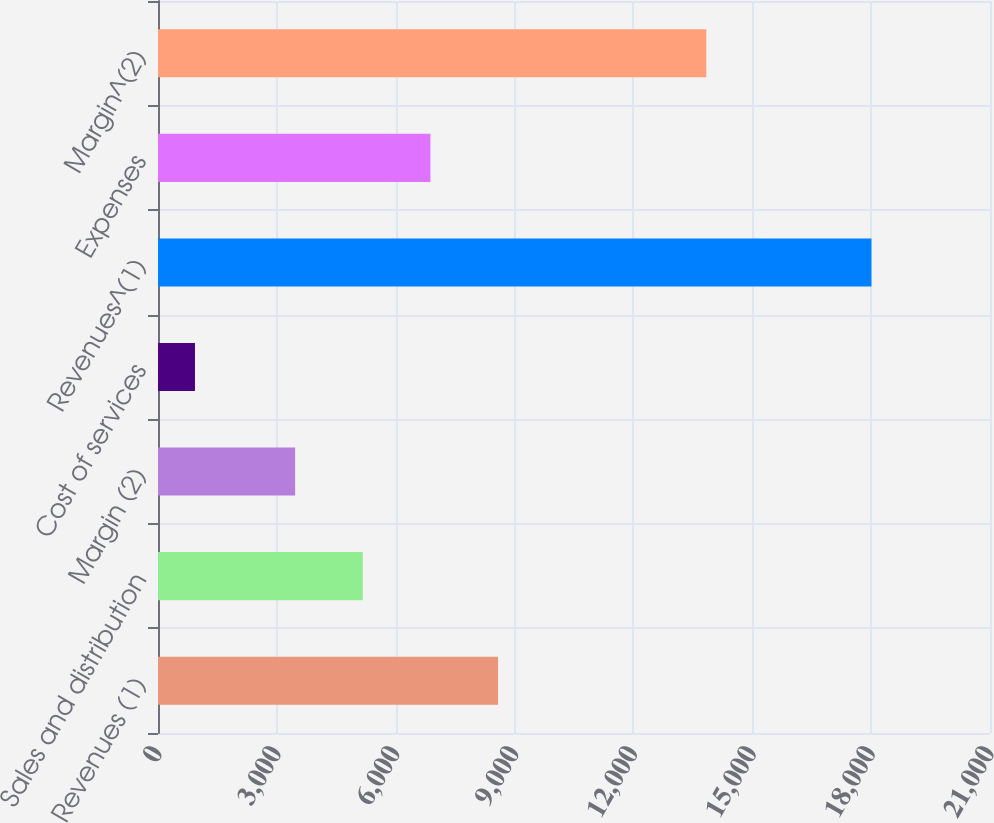<chart> <loc_0><loc_0><loc_500><loc_500><bar_chart><fcel>Revenues (1)<fcel>Sales and distribution<fcel>Margin (2)<fcel>Cost of services<fcel>Revenues^(1)<fcel>Expenses<fcel>Margin^(2)<nl><fcel>8583.5<fcel>5168.5<fcel>3461<fcel>933<fcel>18008<fcel>6876<fcel>13839<nl></chart> 